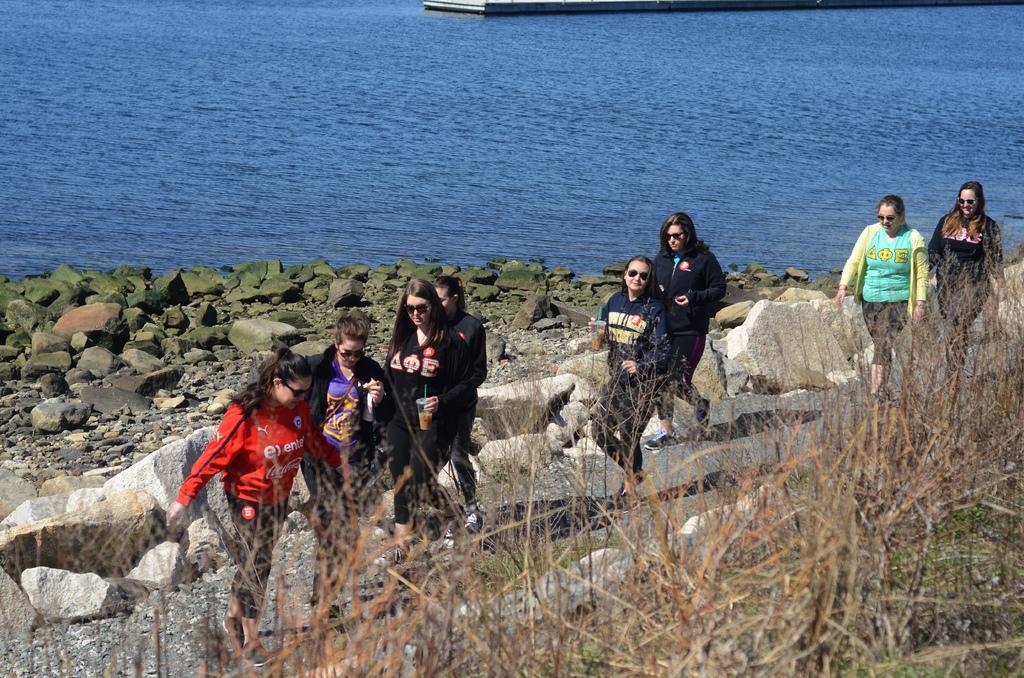Could you give a brief overview of what you see in this image? In this image we can see few people. They are wearing goggles. There are rocks. In the back there is water. Also there is grass. 